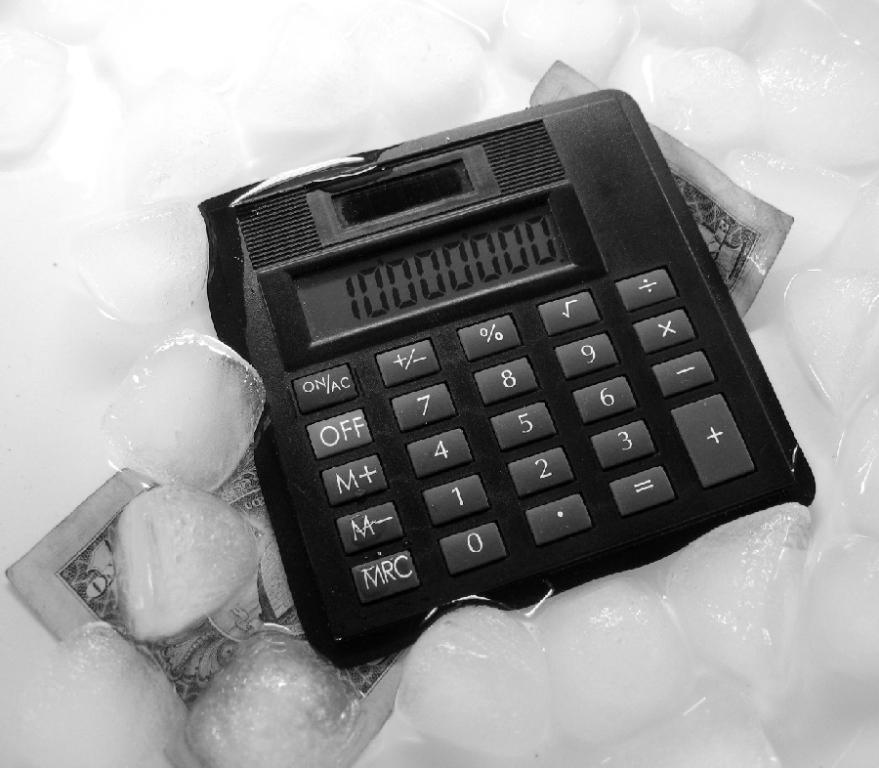What is the value of the bill below the calculator?
Keep it short and to the point. 1. Where is the off located?
Your response must be concise. Under the on button. 